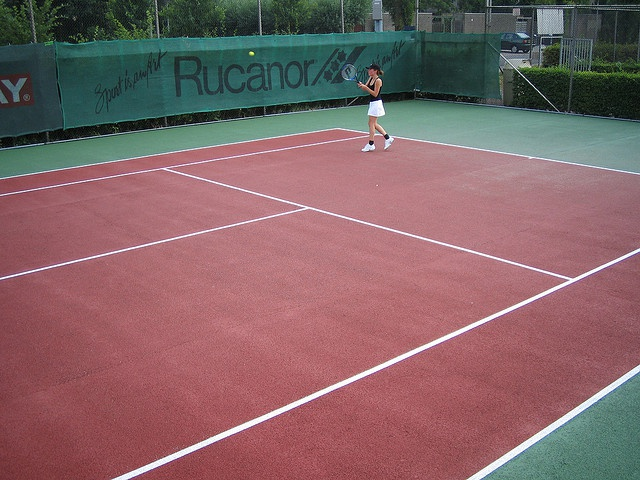Describe the objects in this image and their specific colors. I can see people in darkgreen, lavender, brown, black, and lightpink tones, car in darkgreen, black, blue, gray, and darkblue tones, tennis racket in darkgreen, gray, and blue tones, and sports ball in darkgreen, green, lightgreen, and khaki tones in this image. 